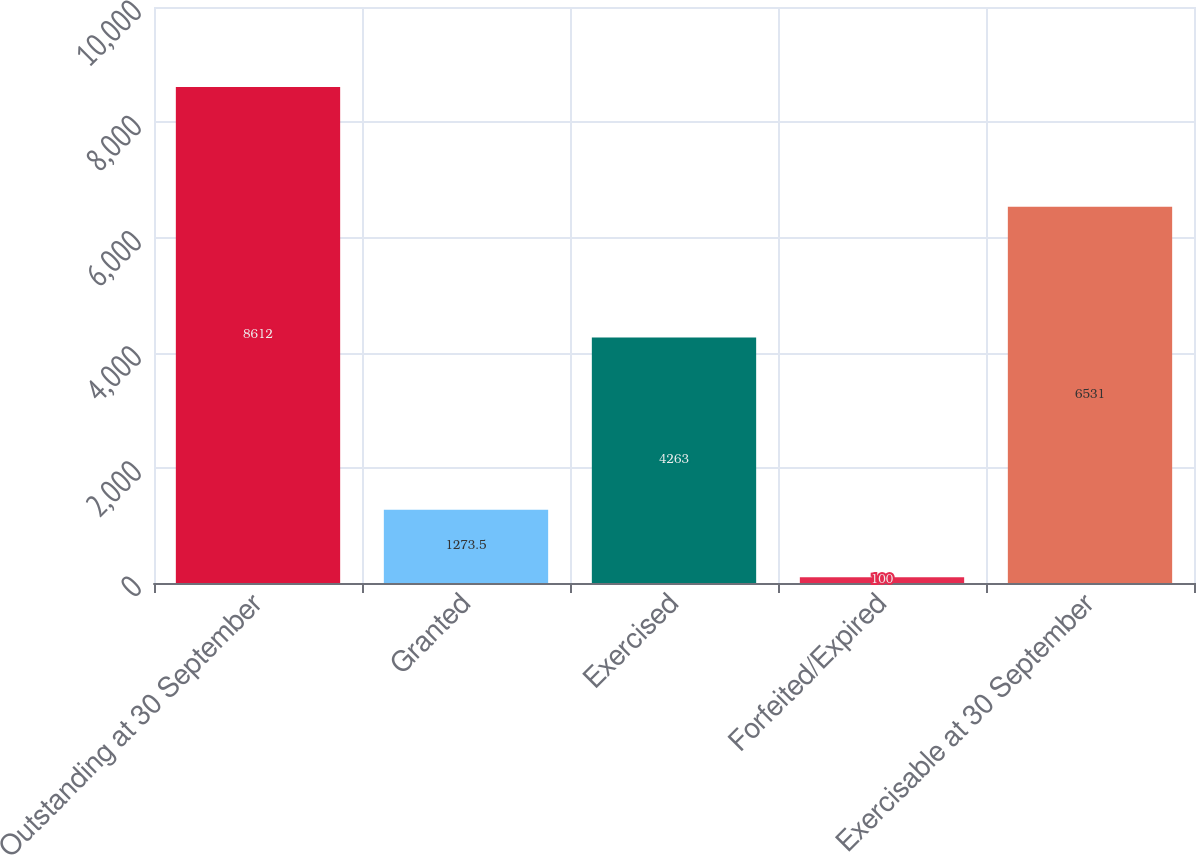<chart> <loc_0><loc_0><loc_500><loc_500><bar_chart><fcel>Outstanding at 30 September<fcel>Granted<fcel>Exercised<fcel>Forfeited/Expired<fcel>Exercisable at 30 September<nl><fcel>8612<fcel>1273.5<fcel>4263<fcel>100<fcel>6531<nl></chart> 